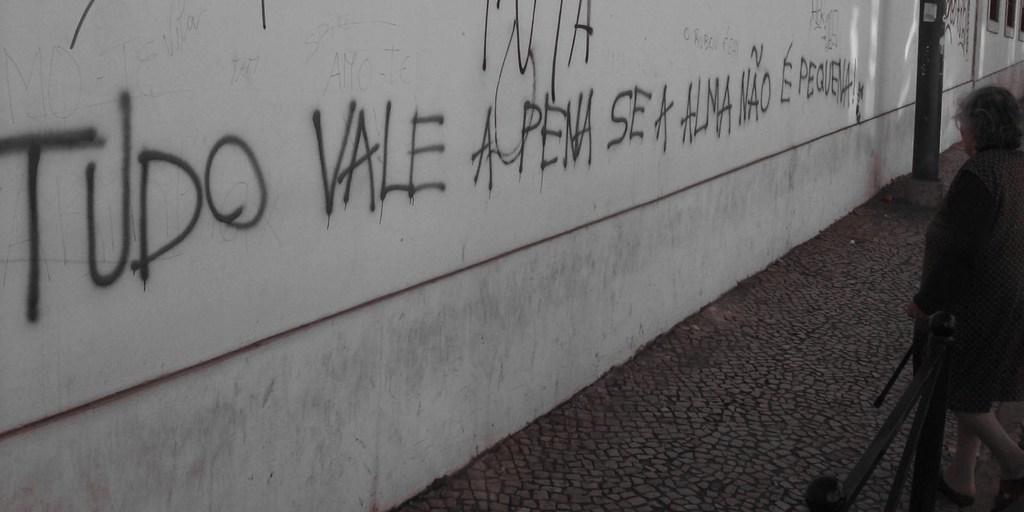In one or two sentences, can you explain what this image depicts? In this image there is some text written on the wall, in front of the wall there is a metal rod pillar, metal rod fence, in front of the fence there is a woman standing. 